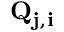Convert formula to latex. <formula><loc_0><loc_0><loc_500><loc_500>Q _ { j , i }</formula> 